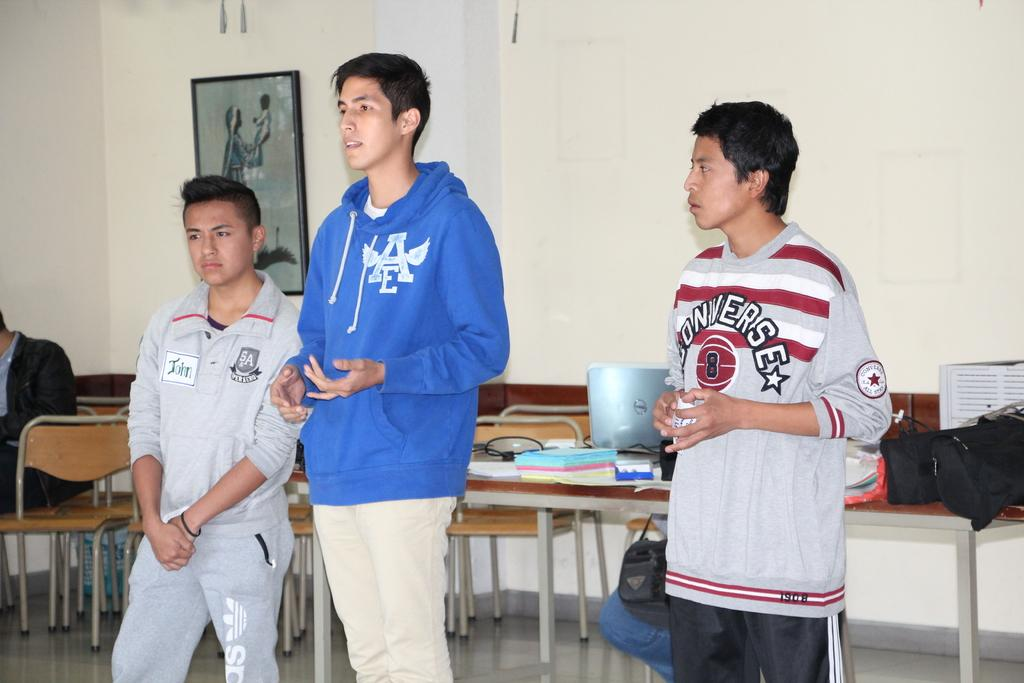<image>
Share a concise interpretation of the image provided. 3 men are standing in front of chairs wearing different shirts, including the blue one with AE logo. 